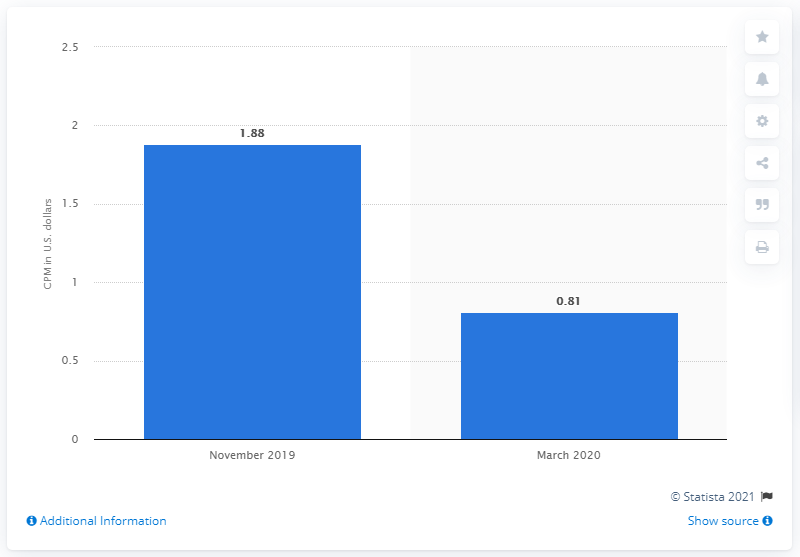Specify some key components in this picture. In November 2019, the cost per thousand impressions (CPM) on Facebook was 1.88. 